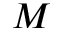Convert formula to latex. <formula><loc_0><loc_0><loc_500><loc_500>M</formula> 